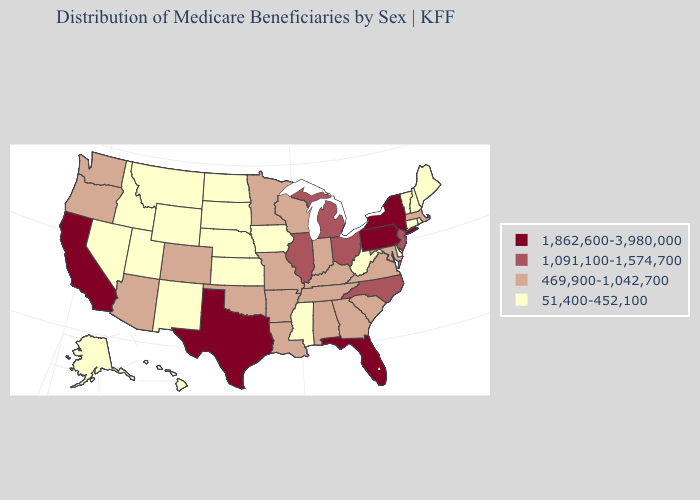What is the lowest value in the USA?
Quick response, please. 51,400-452,100. Name the states that have a value in the range 1,862,600-3,980,000?
Write a very short answer. California, Florida, New York, Pennsylvania, Texas. Does Wisconsin have the lowest value in the MidWest?
Quick response, please. No. Name the states that have a value in the range 51,400-452,100?
Be succinct. Alaska, Connecticut, Delaware, Hawaii, Idaho, Iowa, Kansas, Maine, Mississippi, Montana, Nebraska, Nevada, New Hampshire, New Mexico, North Dakota, Rhode Island, South Dakota, Utah, Vermont, West Virginia, Wyoming. What is the highest value in the USA?
Be succinct. 1,862,600-3,980,000. Name the states that have a value in the range 1,091,100-1,574,700?
Be succinct. Illinois, Michigan, New Jersey, North Carolina, Ohio. What is the lowest value in the West?
Keep it brief. 51,400-452,100. Does Arizona have the highest value in the West?
Short answer required. No. Which states have the highest value in the USA?
Be succinct. California, Florida, New York, Pennsylvania, Texas. Which states have the lowest value in the USA?
Keep it brief. Alaska, Connecticut, Delaware, Hawaii, Idaho, Iowa, Kansas, Maine, Mississippi, Montana, Nebraska, Nevada, New Hampshire, New Mexico, North Dakota, Rhode Island, South Dakota, Utah, Vermont, West Virginia, Wyoming. Does Iowa have a lower value than Georgia?
Concise answer only. Yes. Does the first symbol in the legend represent the smallest category?
Give a very brief answer. No. What is the value of Iowa?
Write a very short answer. 51,400-452,100. Does Illinois have the same value as Ohio?
Answer briefly. Yes. 